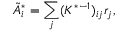<formula> <loc_0><loc_0><loc_500><loc_500>\tilde { A } _ { i } ^ { * } = \sum _ { j } ( K ^ { * - 1 } ) _ { i j } r _ { j } ,</formula> 